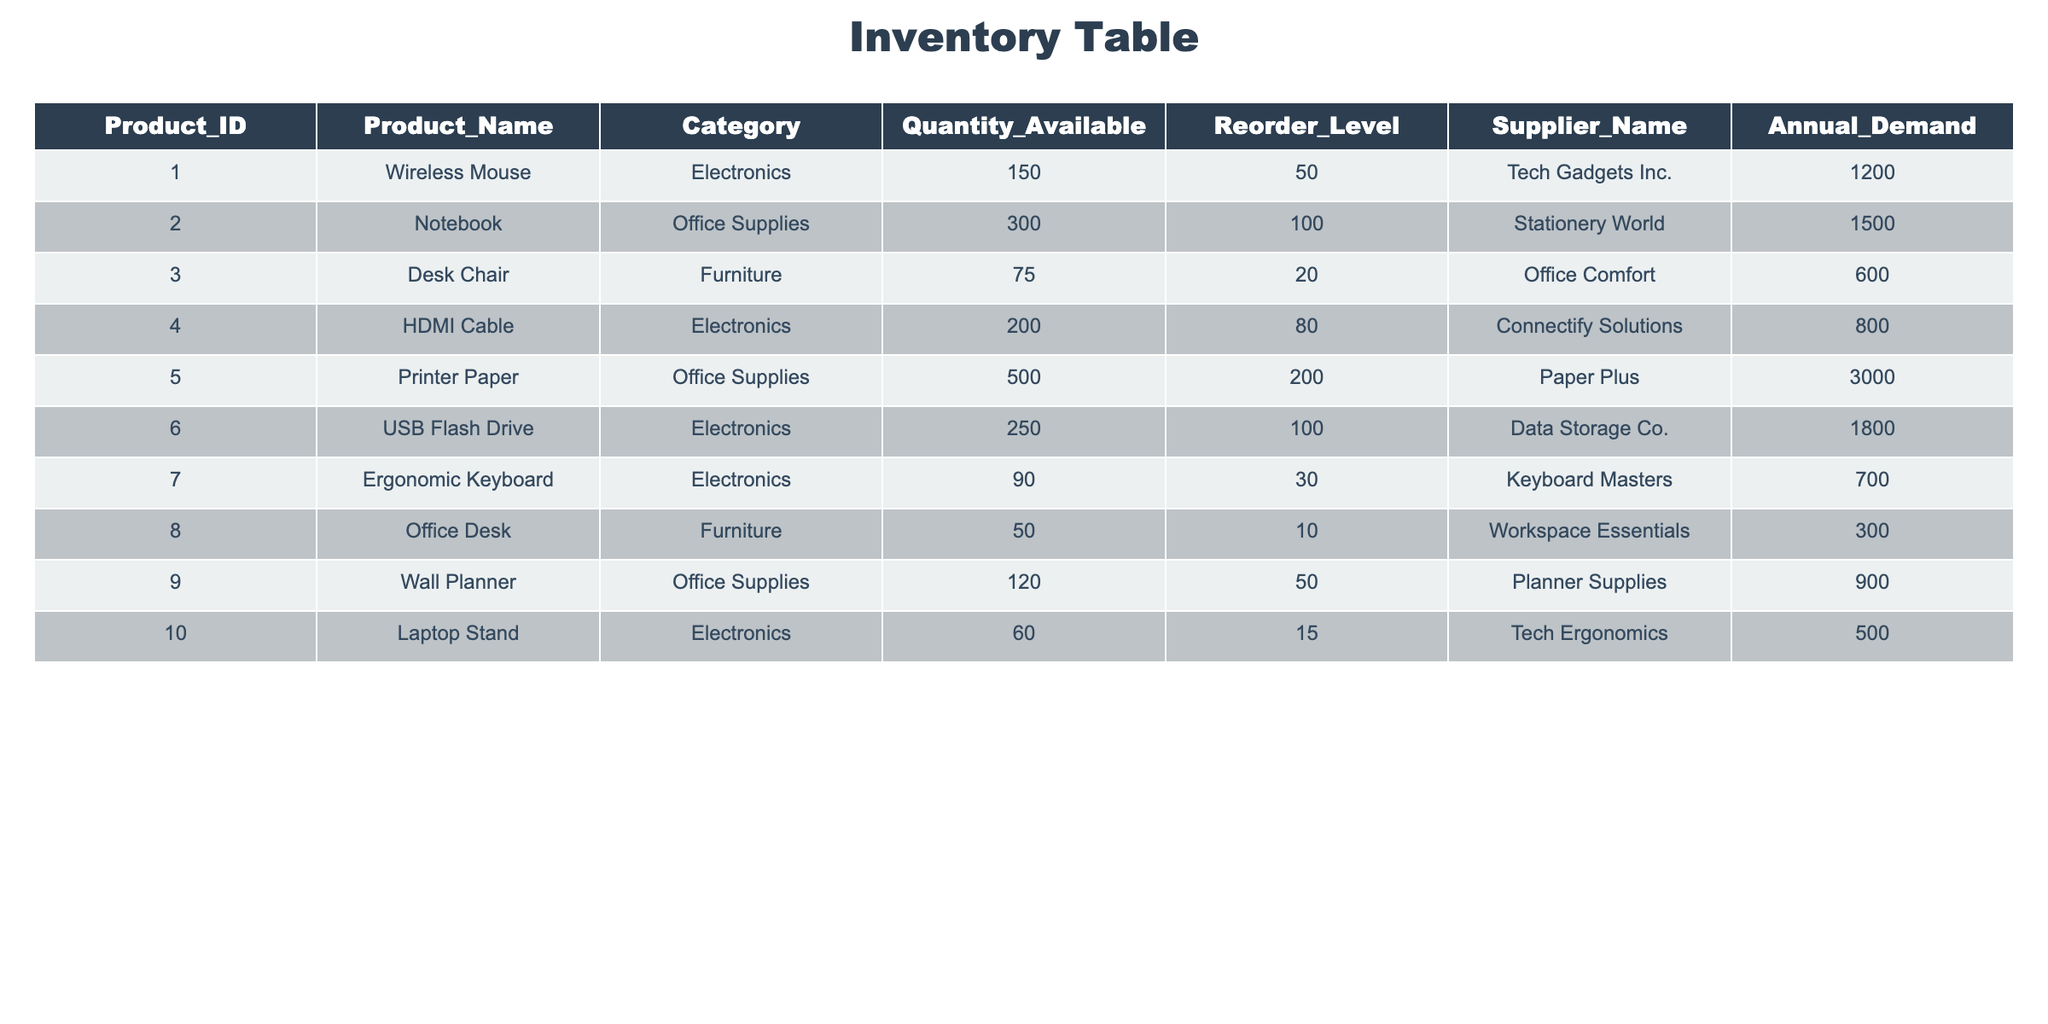What is the product with the highest quantity available? Looking at the Quantity Available column, the highest amount is 500, which corresponds to the product "Printer Paper."
Answer: Printer Paper How many products have a reorder level higher than 50? By examining the Reorder Level column, the products that exceed 50 are: Wireless Mouse, Notebook, HDMI Cable, USB Flash Drive, Printer Paper, and Wall Planner. That totals to 6 products.
Answer: 6 What is the annual demand for USB Flash Drive? The annual demand listed in the table for USB Flash Drive is 1800.
Answer: 1800 Is there any product with an annual demand less than 600? Checking the Annual Demand column, the product "Desk Chair" has an annual demand of 600, and all others have a demand equal to or higher than that. Thus, there are no products with a demand less than 600.
Answer: No What is the difference between the highest and lowest annual demand? The highest annual demand is for Printer Paper at 3000, and the lowest is for Desk Chair at 600. The difference is calculated as 3000 - 600 = 2400.
Answer: 2400 What is the average quantity available for all the products? To find the average, add the quantities: 150 + 300 + 75 + 200 + 500 + 250 + 90 + 50 + 120 + 60 = 1995. Then divide by the number of products (10): 1995 / 10 = 199.5.
Answer: 199.5 Which supplier has the most products listed? By checking each product's Supplier Name, the suppliers are: "Tech Gadgets Inc." (1), "Stationery World" (1), "Office Comfort" (1), "Connectify Solutions" (1), "Paper Plus" (1), "Data Storage Co." (1), "Keyboard Masters" (1), "Workspace Essentials" (1), and "Tech Ergonomics" (1). All suppliers have one product listed, meaning no single supplier has more than others.
Answer: None, all suppliers have one product 